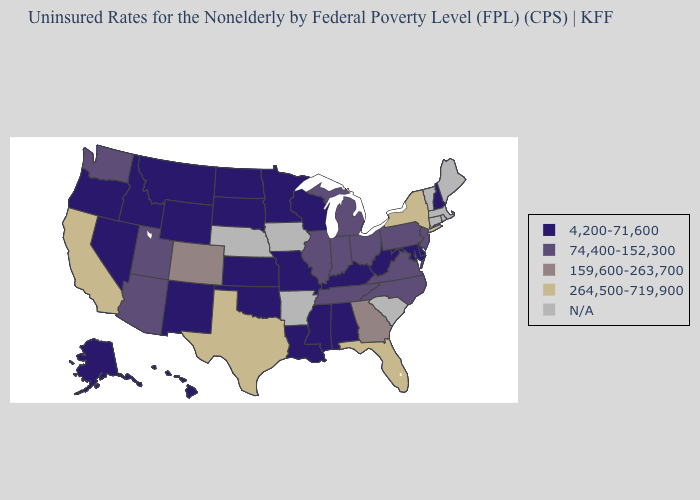What is the value of Alaska?
Give a very brief answer. 4,200-71,600. Name the states that have a value in the range 264,500-719,900?
Concise answer only. California, Florida, New York, Texas. Does Missouri have the highest value in the MidWest?
Give a very brief answer. No. Among the states that border Nevada , which have the highest value?
Write a very short answer. California. Does the map have missing data?
Be succinct. Yes. Does Washington have the highest value in the USA?
Give a very brief answer. No. Name the states that have a value in the range 74,400-152,300?
Be succinct. Arizona, Illinois, Indiana, Michigan, New Jersey, North Carolina, Ohio, Pennsylvania, Tennessee, Utah, Virginia, Washington. What is the value of Mississippi?
Give a very brief answer. 4,200-71,600. Name the states that have a value in the range 74,400-152,300?
Concise answer only. Arizona, Illinois, Indiana, Michigan, New Jersey, North Carolina, Ohio, Pennsylvania, Tennessee, Utah, Virginia, Washington. Name the states that have a value in the range 159,600-263,700?
Quick response, please. Colorado, Georgia. Which states have the lowest value in the USA?
Keep it brief. Alabama, Alaska, Delaware, Hawaii, Idaho, Kansas, Kentucky, Louisiana, Maryland, Minnesota, Mississippi, Missouri, Montana, Nevada, New Hampshire, New Mexico, North Dakota, Oklahoma, Oregon, South Dakota, West Virginia, Wisconsin, Wyoming. Does the map have missing data?
Be succinct. Yes. Does Pennsylvania have the highest value in the Northeast?
Short answer required. No. 